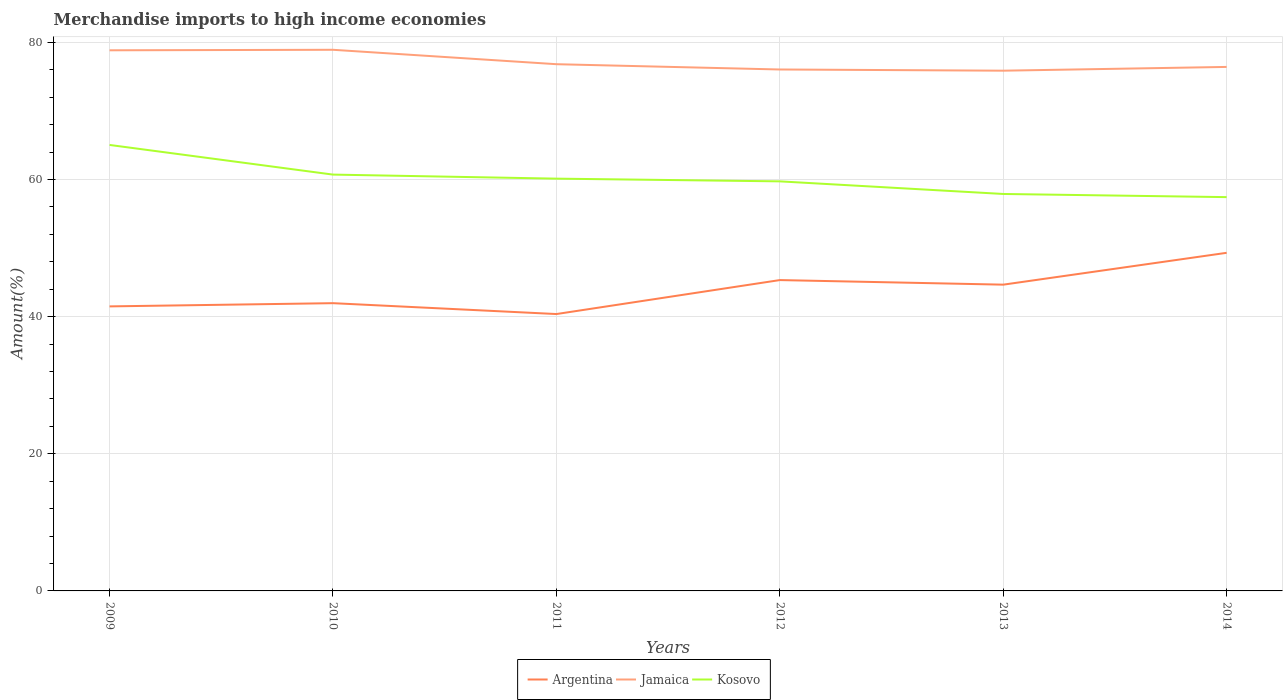How many different coloured lines are there?
Ensure brevity in your answer.  3. Is the number of lines equal to the number of legend labels?
Make the answer very short. Yes. Across all years, what is the maximum percentage of amount earned from merchandise imports in Jamaica?
Your answer should be compact. 75.86. What is the total percentage of amount earned from merchandise imports in Kosovo in the graph?
Provide a short and direct response. 2.69. What is the difference between the highest and the second highest percentage of amount earned from merchandise imports in Jamaica?
Your answer should be compact. 3.05. How many lines are there?
Your answer should be very brief. 3. Are the values on the major ticks of Y-axis written in scientific E-notation?
Keep it short and to the point. No. Does the graph contain any zero values?
Give a very brief answer. No. Where does the legend appear in the graph?
Your answer should be compact. Bottom center. How are the legend labels stacked?
Provide a short and direct response. Horizontal. What is the title of the graph?
Ensure brevity in your answer.  Merchandise imports to high income economies. Does "Antigua and Barbuda" appear as one of the legend labels in the graph?
Provide a succinct answer. No. What is the label or title of the X-axis?
Provide a succinct answer. Years. What is the label or title of the Y-axis?
Ensure brevity in your answer.  Amount(%). What is the Amount(%) of Argentina in 2009?
Provide a succinct answer. 41.49. What is the Amount(%) of Jamaica in 2009?
Give a very brief answer. 78.84. What is the Amount(%) of Kosovo in 2009?
Your answer should be very brief. 65.03. What is the Amount(%) in Argentina in 2010?
Your response must be concise. 41.96. What is the Amount(%) of Jamaica in 2010?
Offer a very short reply. 78.91. What is the Amount(%) in Kosovo in 2010?
Make the answer very short. 60.71. What is the Amount(%) in Argentina in 2011?
Give a very brief answer. 40.37. What is the Amount(%) in Jamaica in 2011?
Give a very brief answer. 76.81. What is the Amount(%) in Kosovo in 2011?
Your response must be concise. 60.12. What is the Amount(%) of Argentina in 2012?
Make the answer very short. 45.33. What is the Amount(%) of Jamaica in 2012?
Ensure brevity in your answer.  76.04. What is the Amount(%) of Kosovo in 2012?
Give a very brief answer. 59.72. What is the Amount(%) in Argentina in 2013?
Provide a short and direct response. 44.66. What is the Amount(%) in Jamaica in 2013?
Your answer should be very brief. 75.86. What is the Amount(%) in Kosovo in 2013?
Your answer should be very brief. 57.88. What is the Amount(%) in Argentina in 2014?
Ensure brevity in your answer.  49.3. What is the Amount(%) in Jamaica in 2014?
Provide a succinct answer. 76.41. What is the Amount(%) of Kosovo in 2014?
Offer a terse response. 57.43. Across all years, what is the maximum Amount(%) of Argentina?
Your answer should be compact. 49.3. Across all years, what is the maximum Amount(%) of Jamaica?
Provide a succinct answer. 78.91. Across all years, what is the maximum Amount(%) of Kosovo?
Ensure brevity in your answer.  65.03. Across all years, what is the minimum Amount(%) of Argentina?
Ensure brevity in your answer.  40.37. Across all years, what is the minimum Amount(%) of Jamaica?
Ensure brevity in your answer.  75.86. Across all years, what is the minimum Amount(%) of Kosovo?
Give a very brief answer. 57.43. What is the total Amount(%) in Argentina in the graph?
Keep it short and to the point. 263.12. What is the total Amount(%) in Jamaica in the graph?
Ensure brevity in your answer.  462.87. What is the total Amount(%) of Kosovo in the graph?
Offer a terse response. 360.9. What is the difference between the Amount(%) in Argentina in 2009 and that in 2010?
Provide a short and direct response. -0.47. What is the difference between the Amount(%) of Jamaica in 2009 and that in 2010?
Keep it short and to the point. -0.07. What is the difference between the Amount(%) of Kosovo in 2009 and that in 2010?
Your answer should be very brief. 4.32. What is the difference between the Amount(%) of Argentina in 2009 and that in 2011?
Offer a terse response. 1.12. What is the difference between the Amount(%) of Jamaica in 2009 and that in 2011?
Make the answer very short. 2.03. What is the difference between the Amount(%) in Kosovo in 2009 and that in 2011?
Offer a terse response. 4.91. What is the difference between the Amount(%) of Argentina in 2009 and that in 2012?
Keep it short and to the point. -3.84. What is the difference between the Amount(%) in Jamaica in 2009 and that in 2012?
Ensure brevity in your answer.  2.8. What is the difference between the Amount(%) in Kosovo in 2009 and that in 2012?
Offer a very short reply. 5.31. What is the difference between the Amount(%) in Argentina in 2009 and that in 2013?
Offer a very short reply. -3.17. What is the difference between the Amount(%) in Jamaica in 2009 and that in 2013?
Offer a very short reply. 2.97. What is the difference between the Amount(%) of Kosovo in 2009 and that in 2013?
Your answer should be compact. 7.15. What is the difference between the Amount(%) of Argentina in 2009 and that in 2014?
Your answer should be very brief. -7.81. What is the difference between the Amount(%) of Jamaica in 2009 and that in 2014?
Your answer should be compact. 2.42. What is the difference between the Amount(%) of Kosovo in 2009 and that in 2014?
Give a very brief answer. 7.61. What is the difference between the Amount(%) of Argentina in 2010 and that in 2011?
Offer a very short reply. 1.59. What is the difference between the Amount(%) of Jamaica in 2010 and that in 2011?
Your answer should be very brief. 2.1. What is the difference between the Amount(%) of Kosovo in 2010 and that in 2011?
Your response must be concise. 0.59. What is the difference between the Amount(%) of Argentina in 2010 and that in 2012?
Offer a very short reply. -3.37. What is the difference between the Amount(%) of Jamaica in 2010 and that in 2012?
Give a very brief answer. 2.87. What is the difference between the Amount(%) in Kosovo in 2010 and that in 2012?
Provide a succinct answer. 0.99. What is the difference between the Amount(%) of Argentina in 2010 and that in 2013?
Provide a succinct answer. -2.7. What is the difference between the Amount(%) in Jamaica in 2010 and that in 2013?
Provide a succinct answer. 3.05. What is the difference between the Amount(%) of Kosovo in 2010 and that in 2013?
Keep it short and to the point. 2.83. What is the difference between the Amount(%) in Argentina in 2010 and that in 2014?
Ensure brevity in your answer.  -7.34. What is the difference between the Amount(%) in Jamaica in 2010 and that in 2014?
Make the answer very short. 2.5. What is the difference between the Amount(%) in Kosovo in 2010 and that in 2014?
Offer a terse response. 3.28. What is the difference between the Amount(%) of Argentina in 2011 and that in 2012?
Provide a short and direct response. -4.95. What is the difference between the Amount(%) in Jamaica in 2011 and that in 2012?
Provide a succinct answer. 0.77. What is the difference between the Amount(%) of Kosovo in 2011 and that in 2012?
Provide a short and direct response. 0.4. What is the difference between the Amount(%) in Argentina in 2011 and that in 2013?
Provide a short and direct response. -4.29. What is the difference between the Amount(%) in Jamaica in 2011 and that in 2013?
Give a very brief answer. 0.95. What is the difference between the Amount(%) of Kosovo in 2011 and that in 2013?
Offer a very short reply. 2.24. What is the difference between the Amount(%) of Argentina in 2011 and that in 2014?
Provide a short and direct response. -8.93. What is the difference between the Amount(%) of Jamaica in 2011 and that in 2014?
Give a very brief answer. 0.4. What is the difference between the Amount(%) in Kosovo in 2011 and that in 2014?
Make the answer very short. 2.69. What is the difference between the Amount(%) of Argentina in 2012 and that in 2013?
Make the answer very short. 0.67. What is the difference between the Amount(%) of Jamaica in 2012 and that in 2013?
Make the answer very short. 0.17. What is the difference between the Amount(%) in Kosovo in 2012 and that in 2013?
Provide a short and direct response. 1.84. What is the difference between the Amount(%) in Argentina in 2012 and that in 2014?
Make the answer very short. -3.98. What is the difference between the Amount(%) in Jamaica in 2012 and that in 2014?
Your response must be concise. -0.38. What is the difference between the Amount(%) in Kosovo in 2012 and that in 2014?
Provide a succinct answer. 2.3. What is the difference between the Amount(%) of Argentina in 2013 and that in 2014?
Keep it short and to the point. -4.64. What is the difference between the Amount(%) in Jamaica in 2013 and that in 2014?
Offer a very short reply. -0.55. What is the difference between the Amount(%) of Kosovo in 2013 and that in 2014?
Keep it short and to the point. 0.46. What is the difference between the Amount(%) in Argentina in 2009 and the Amount(%) in Jamaica in 2010?
Make the answer very short. -37.42. What is the difference between the Amount(%) in Argentina in 2009 and the Amount(%) in Kosovo in 2010?
Your response must be concise. -19.22. What is the difference between the Amount(%) of Jamaica in 2009 and the Amount(%) of Kosovo in 2010?
Ensure brevity in your answer.  18.13. What is the difference between the Amount(%) in Argentina in 2009 and the Amount(%) in Jamaica in 2011?
Provide a succinct answer. -35.32. What is the difference between the Amount(%) in Argentina in 2009 and the Amount(%) in Kosovo in 2011?
Your response must be concise. -18.63. What is the difference between the Amount(%) of Jamaica in 2009 and the Amount(%) of Kosovo in 2011?
Your response must be concise. 18.72. What is the difference between the Amount(%) in Argentina in 2009 and the Amount(%) in Jamaica in 2012?
Offer a terse response. -34.55. What is the difference between the Amount(%) of Argentina in 2009 and the Amount(%) of Kosovo in 2012?
Your response must be concise. -18.23. What is the difference between the Amount(%) of Jamaica in 2009 and the Amount(%) of Kosovo in 2012?
Provide a succinct answer. 19.11. What is the difference between the Amount(%) of Argentina in 2009 and the Amount(%) of Jamaica in 2013?
Offer a very short reply. -34.37. What is the difference between the Amount(%) of Argentina in 2009 and the Amount(%) of Kosovo in 2013?
Give a very brief answer. -16.39. What is the difference between the Amount(%) in Jamaica in 2009 and the Amount(%) in Kosovo in 2013?
Your response must be concise. 20.95. What is the difference between the Amount(%) of Argentina in 2009 and the Amount(%) of Jamaica in 2014?
Provide a succinct answer. -34.92. What is the difference between the Amount(%) in Argentina in 2009 and the Amount(%) in Kosovo in 2014?
Your answer should be compact. -15.93. What is the difference between the Amount(%) of Jamaica in 2009 and the Amount(%) of Kosovo in 2014?
Provide a succinct answer. 21.41. What is the difference between the Amount(%) of Argentina in 2010 and the Amount(%) of Jamaica in 2011?
Your response must be concise. -34.85. What is the difference between the Amount(%) of Argentina in 2010 and the Amount(%) of Kosovo in 2011?
Your response must be concise. -18.16. What is the difference between the Amount(%) of Jamaica in 2010 and the Amount(%) of Kosovo in 2011?
Ensure brevity in your answer.  18.79. What is the difference between the Amount(%) of Argentina in 2010 and the Amount(%) of Jamaica in 2012?
Your response must be concise. -34.08. What is the difference between the Amount(%) of Argentina in 2010 and the Amount(%) of Kosovo in 2012?
Keep it short and to the point. -17.76. What is the difference between the Amount(%) in Jamaica in 2010 and the Amount(%) in Kosovo in 2012?
Keep it short and to the point. 19.19. What is the difference between the Amount(%) of Argentina in 2010 and the Amount(%) of Jamaica in 2013?
Your response must be concise. -33.9. What is the difference between the Amount(%) of Argentina in 2010 and the Amount(%) of Kosovo in 2013?
Your answer should be very brief. -15.92. What is the difference between the Amount(%) in Jamaica in 2010 and the Amount(%) in Kosovo in 2013?
Provide a short and direct response. 21.03. What is the difference between the Amount(%) in Argentina in 2010 and the Amount(%) in Jamaica in 2014?
Provide a short and direct response. -34.45. What is the difference between the Amount(%) of Argentina in 2010 and the Amount(%) of Kosovo in 2014?
Give a very brief answer. -15.47. What is the difference between the Amount(%) of Jamaica in 2010 and the Amount(%) of Kosovo in 2014?
Provide a succinct answer. 21.48. What is the difference between the Amount(%) in Argentina in 2011 and the Amount(%) in Jamaica in 2012?
Your response must be concise. -35.66. What is the difference between the Amount(%) in Argentina in 2011 and the Amount(%) in Kosovo in 2012?
Make the answer very short. -19.35. What is the difference between the Amount(%) of Jamaica in 2011 and the Amount(%) of Kosovo in 2012?
Give a very brief answer. 17.09. What is the difference between the Amount(%) of Argentina in 2011 and the Amount(%) of Jamaica in 2013?
Offer a very short reply. -35.49. What is the difference between the Amount(%) in Argentina in 2011 and the Amount(%) in Kosovo in 2013?
Make the answer very short. -17.51. What is the difference between the Amount(%) in Jamaica in 2011 and the Amount(%) in Kosovo in 2013?
Offer a terse response. 18.92. What is the difference between the Amount(%) in Argentina in 2011 and the Amount(%) in Jamaica in 2014?
Offer a very short reply. -36.04. What is the difference between the Amount(%) in Argentina in 2011 and the Amount(%) in Kosovo in 2014?
Make the answer very short. -17.05. What is the difference between the Amount(%) in Jamaica in 2011 and the Amount(%) in Kosovo in 2014?
Make the answer very short. 19.38. What is the difference between the Amount(%) in Argentina in 2012 and the Amount(%) in Jamaica in 2013?
Provide a succinct answer. -30.53. What is the difference between the Amount(%) in Argentina in 2012 and the Amount(%) in Kosovo in 2013?
Your answer should be compact. -12.56. What is the difference between the Amount(%) in Jamaica in 2012 and the Amount(%) in Kosovo in 2013?
Your answer should be very brief. 18.15. What is the difference between the Amount(%) of Argentina in 2012 and the Amount(%) of Jamaica in 2014?
Offer a terse response. -31.08. What is the difference between the Amount(%) in Argentina in 2012 and the Amount(%) in Kosovo in 2014?
Offer a very short reply. -12.1. What is the difference between the Amount(%) in Jamaica in 2012 and the Amount(%) in Kosovo in 2014?
Ensure brevity in your answer.  18.61. What is the difference between the Amount(%) in Argentina in 2013 and the Amount(%) in Jamaica in 2014?
Offer a very short reply. -31.75. What is the difference between the Amount(%) in Argentina in 2013 and the Amount(%) in Kosovo in 2014?
Give a very brief answer. -12.77. What is the difference between the Amount(%) of Jamaica in 2013 and the Amount(%) of Kosovo in 2014?
Offer a very short reply. 18.44. What is the average Amount(%) of Argentina per year?
Give a very brief answer. 43.85. What is the average Amount(%) of Jamaica per year?
Give a very brief answer. 77.14. What is the average Amount(%) in Kosovo per year?
Keep it short and to the point. 60.15. In the year 2009, what is the difference between the Amount(%) in Argentina and Amount(%) in Jamaica?
Ensure brevity in your answer.  -37.34. In the year 2009, what is the difference between the Amount(%) of Argentina and Amount(%) of Kosovo?
Offer a very short reply. -23.54. In the year 2009, what is the difference between the Amount(%) in Jamaica and Amount(%) in Kosovo?
Provide a succinct answer. 13.8. In the year 2010, what is the difference between the Amount(%) of Argentina and Amount(%) of Jamaica?
Your answer should be very brief. -36.95. In the year 2010, what is the difference between the Amount(%) of Argentina and Amount(%) of Kosovo?
Provide a short and direct response. -18.75. In the year 2010, what is the difference between the Amount(%) of Jamaica and Amount(%) of Kosovo?
Offer a very short reply. 18.2. In the year 2011, what is the difference between the Amount(%) of Argentina and Amount(%) of Jamaica?
Give a very brief answer. -36.43. In the year 2011, what is the difference between the Amount(%) in Argentina and Amount(%) in Kosovo?
Provide a succinct answer. -19.75. In the year 2011, what is the difference between the Amount(%) in Jamaica and Amount(%) in Kosovo?
Offer a terse response. 16.69. In the year 2012, what is the difference between the Amount(%) of Argentina and Amount(%) of Jamaica?
Your answer should be compact. -30.71. In the year 2012, what is the difference between the Amount(%) in Argentina and Amount(%) in Kosovo?
Provide a succinct answer. -14.39. In the year 2012, what is the difference between the Amount(%) in Jamaica and Amount(%) in Kosovo?
Keep it short and to the point. 16.31. In the year 2013, what is the difference between the Amount(%) of Argentina and Amount(%) of Jamaica?
Your response must be concise. -31.2. In the year 2013, what is the difference between the Amount(%) of Argentina and Amount(%) of Kosovo?
Give a very brief answer. -13.22. In the year 2013, what is the difference between the Amount(%) of Jamaica and Amount(%) of Kosovo?
Your response must be concise. 17.98. In the year 2014, what is the difference between the Amount(%) in Argentina and Amount(%) in Jamaica?
Make the answer very short. -27.11. In the year 2014, what is the difference between the Amount(%) in Argentina and Amount(%) in Kosovo?
Your answer should be very brief. -8.12. In the year 2014, what is the difference between the Amount(%) of Jamaica and Amount(%) of Kosovo?
Provide a short and direct response. 18.99. What is the ratio of the Amount(%) in Argentina in 2009 to that in 2010?
Ensure brevity in your answer.  0.99. What is the ratio of the Amount(%) in Kosovo in 2009 to that in 2010?
Your response must be concise. 1.07. What is the ratio of the Amount(%) in Argentina in 2009 to that in 2011?
Your answer should be compact. 1.03. What is the ratio of the Amount(%) of Jamaica in 2009 to that in 2011?
Your response must be concise. 1.03. What is the ratio of the Amount(%) of Kosovo in 2009 to that in 2011?
Keep it short and to the point. 1.08. What is the ratio of the Amount(%) of Argentina in 2009 to that in 2012?
Your response must be concise. 0.92. What is the ratio of the Amount(%) of Jamaica in 2009 to that in 2012?
Keep it short and to the point. 1.04. What is the ratio of the Amount(%) in Kosovo in 2009 to that in 2012?
Your answer should be very brief. 1.09. What is the ratio of the Amount(%) in Argentina in 2009 to that in 2013?
Make the answer very short. 0.93. What is the ratio of the Amount(%) of Jamaica in 2009 to that in 2013?
Give a very brief answer. 1.04. What is the ratio of the Amount(%) of Kosovo in 2009 to that in 2013?
Provide a short and direct response. 1.12. What is the ratio of the Amount(%) in Argentina in 2009 to that in 2014?
Ensure brevity in your answer.  0.84. What is the ratio of the Amount(%) in Jamaica in 2009 to that in 2014?
Ensure brevity in your answer.  1.03. What is the ratio of the Amount(%) of Kosovo in 2009 to that in 2014?
Provide a short and direct response. 1.13. What is the ratio of the Amount(%) in Argentina in 2010 to that in 2011?
Provide a short and direct response. 1.04. What is the ratio of the Amount(%) in Jamaica in 2010 to that in 2011?
Provide a short and direct response. 1.03. What is the ratio of the Amount(%) of Kosovo in 2010 to that in 2011?
Offer a terse response. 1.01. What is the ratio of the Amount(%) in Argentina in 2010 to that in 2012?
Provide a short and direct response. 0.93. What is the ratio of the Amount(%) of Jamaica in 2010 to that in 2012?
Your answer should be compact. 1.04. What is the ratio of the Amount(%) of Kosovo in 2010 to that in 2012?
Ensure brevity in your answer.  1.02. What is the ratio of the Amount(%) of Argentina in 2010 to that in 2013?
Give a very brief answer. 0.94. What is the ratio of the Amount(%) in Jamaica in 2010 to that in 2013?
Your answer should be compact. 1.04. What is the ratio of the Amount(%) of Kosovo in 2010 to that in 2013?
Offer a very short reply. 1.05. What is the ratio of the Amount(%) in Argentina in 2010 to that in 2014?
Your answer should be very brief. 0.85. What is the ratio of the Amount(%) of Jamaica in 2010 to that in 2014?
Your answer should be compact. 1.03. What is the ratio of the Amount(%) of Kosovo in 2010 to that in 2014?
Your answer should be compact. 1.06. What is the ratio of the Amount(%) of Argentina in 2011 to that in 2012?
Provide a short and direct response. 0.89. What is the ratio of the Amount(%) in Jamaica in 2011 to that in 2012?
Provide a short and direct response. 1.01. What is the ratio of the Amount(%) in Kosovo in 2011 to that in 2012?
Give a very brief answer. 1.01. What is the ratio of the Amount(%) of Argentina in 2011 to that in 2013?
Your answer should be very brief. 0.9. What is the ratio of the Amount(%) in Jamaica in 2011 to that in 2013?
Keep it short and to the point. 1.01. What is the ratio of the Amount(%) in Kosovo in 2011 to that in 2013?
Ensure brevity in your answer.  1.04. What is the ratio of the Amount(%) in Argentina in 2011 to that in 2014?
Give a very brief answer. 0.82. What is the ratio of the Amount(%) in Kosovo in 2011 to that in 2014?
Offer a terse response. 1.05. What is the ratio of the Amount(%) in Argentina in 2012 to that in 2013?
Give a very brief answer. 1.01. What is the ratio of the Amount(%) in Jamaica in 2012 to that in 2013?
Your answer should be very brief. 1. What is the ratio of the Amount(%) of Kosovo in 2012 to that in 2013?
Your answer should be very brief. 1.03. What is the ratio of the Amount(%) in Argentina in 2012 to that in 2014?
Give a very brief answer. 0.92. What is the ratio of the Amount(%) of Argentina in 2013 to that in 2014?
Give a very brief answer. 0.91. What is the ratio of the Amount(%) in Jamaica in 2013 to that in 2014?
Make the answer very short. 0.99. What is the difference between the highest and the second highest Amount(%) in Argentina?
Keep it short and to the point. 3.98. What is the difference between the highest and the second highest Amount(%) of Jamaica?
Provide a succinct answer. 0.07. What is the difference between the highest and the second highest Amount(%) in Kosovo?
Ensure brevity in your answer.  4.32. What is the difference between the highest and the lowest Amount(%) of Argentina?
Give a very brief answer. 8.93. What is the difference between the highest and the lowest Amount(%) of Jamaica?
Offer a terse response. 3.05. What is the difference between the highest and the lowest Amount(%) of Kosovo?
Ensure brevity in your answer.  7.61. 